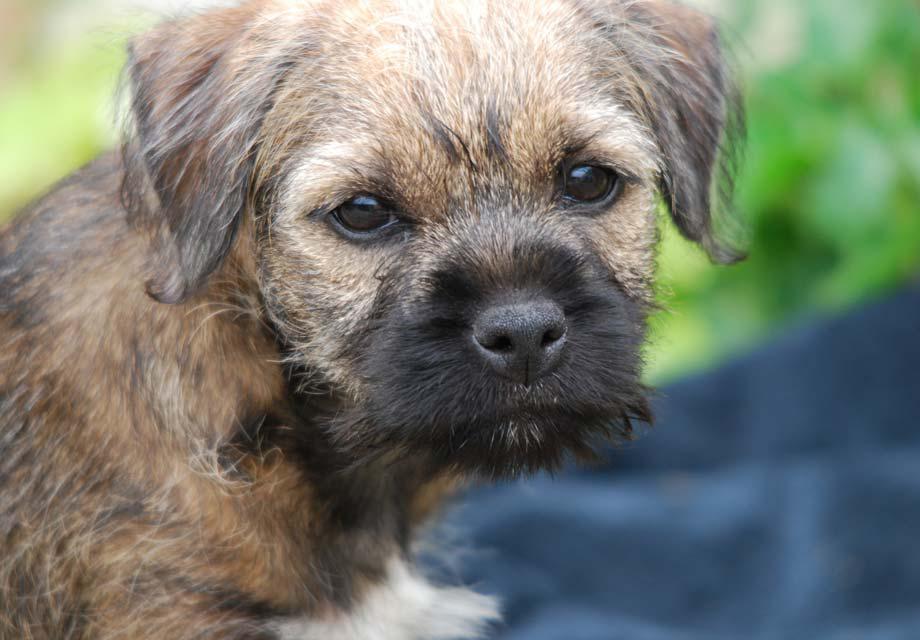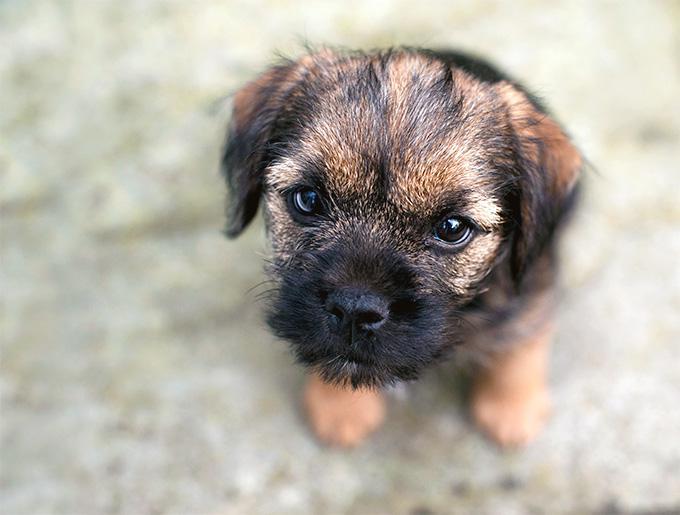The first image is the image on the left, the second image is the image on the right. Analyze the images presented: Is the assertion "The left image shows a dog standing with all four paws on the ground." valid? Answer yes or no. No. 